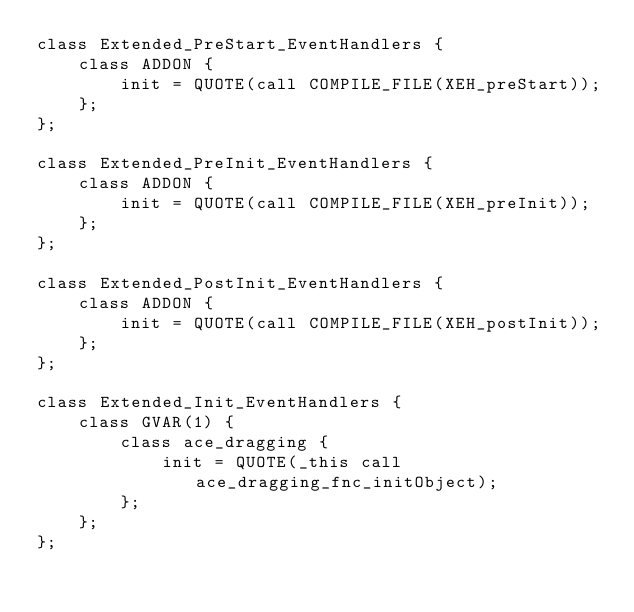<code> <loc_0><loc_0><loc_500><loc_500><_C++_>class Extended_PreStart_EventHandlers {
    class ADDON {
        init = QUOTE(call COMPILE_FILE(XEH_preStart));
    };
};

class Extended_PreInit_EventHandlers {
    class ADDON {
        init = QUOTE(call COMPILE_FILE(XEH_preInit));
    };
};

class Extended_PostInit_EventHandlers {
    class ADDON {
        init = QUOTE(call COMPILE_FILE(XEH_postInit));
    };
};

class Extended_Init_EventHandlers {
    class GVAR(1) {
        class ace_dragging {
            init = QUOTE(_this call ace_dragging_fnc_initObject);
        };
    };
};
</code> 